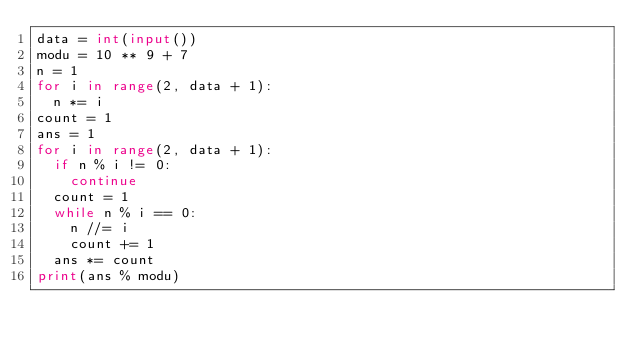Convert code to text. <code><loc_0><loc_0><loc_500><loc_500><_Python_>data = int(input())
modu = 10 ** 9 + 7
n = 1
for i in range(2, data + 1):
  n *= i
count = 1
ans = 1
for i in range(2, data + 1):
  if n % i != 0:
    continue
  count = 1
  while n % i == 0:
    n //= i
    count += 1
  ans *= count
print(ans % modu)</code> 